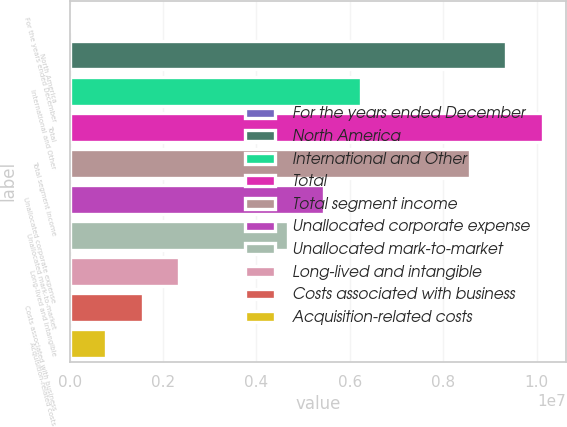Convert chart. <chart><loc_0><loc_0><loc_500><loc_500><bar_chart><fcel>For the years ended December<fcel>North America<fcel>International and Other<fcel>Total<fcel>Total segment income<fcel>Unallocated corporate expense<fcel>Unallocated mark-to-market<fcel>Long-lived and intangible<fcel>Costs associated with business<fcel>Acquisition-related costs<nl><fcel>2018<fcel>9.34888e+06<fcel>6.23326e+06<fcel>1.01278e+07<fcel>8.56997e+06<fcel>5.45435e+06<fcel>4.67545e+06<fcel>2.33873e+06<fcel>1.55983e+06<fcel>780923<nl></chart> 